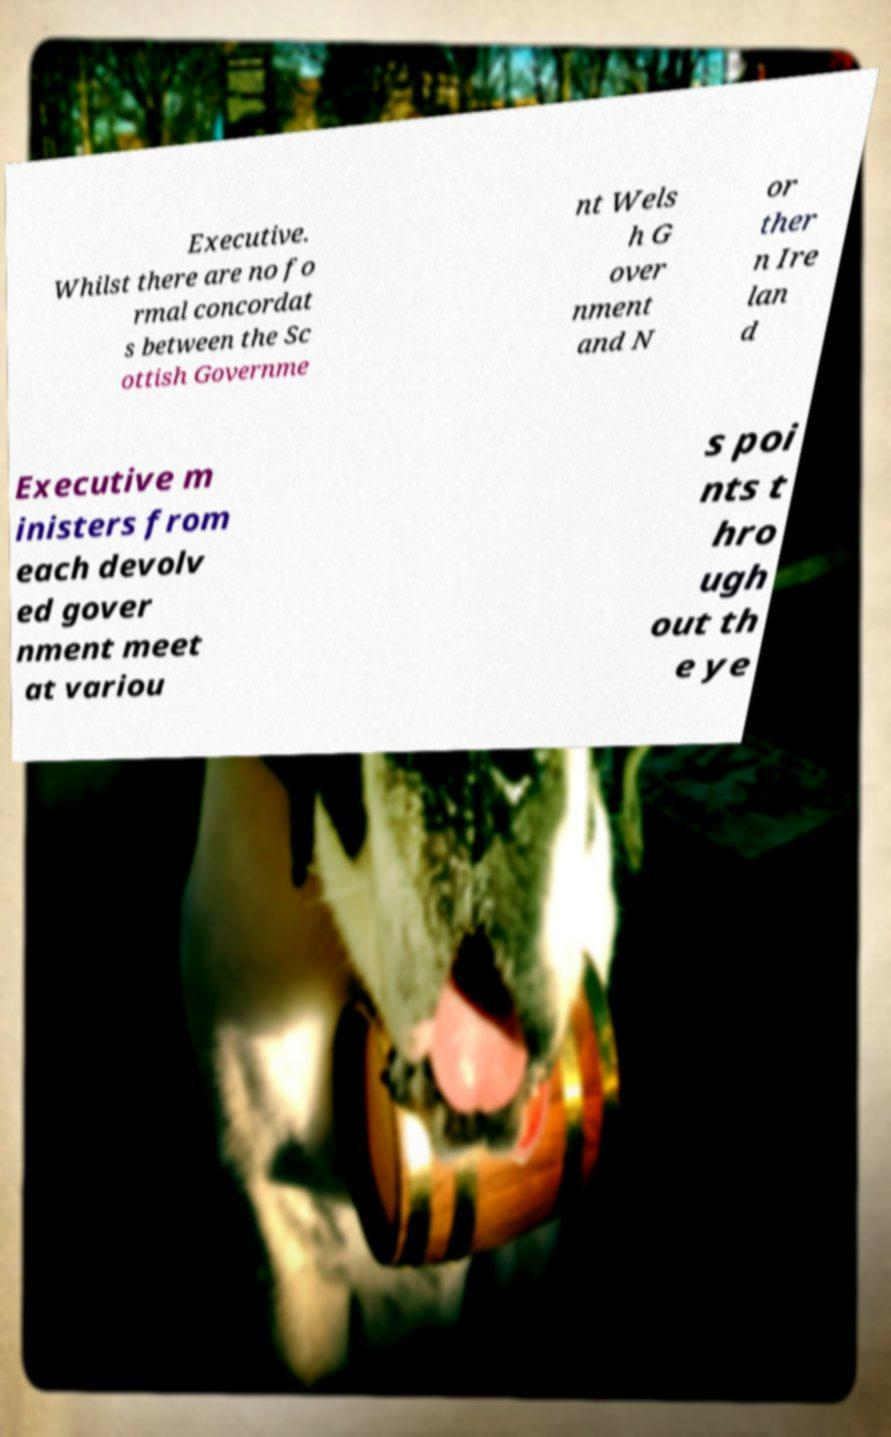Please identify and transcribe the text found in this image. Executive. Whilst there are no fo rmal concordat s between the Sc ottish Governme nt Wels h G over nment and N or ther n Ire lan d Executive m inisters from each devolv ed gover nment meet at variou s poi nts t hro ugh out th e ye 